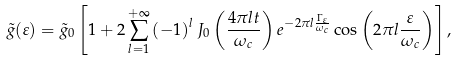<formula> <loc_0><loc_0><loc_500><loc_500>\tilde { g } ( \varepsilon ) = \tilde { g } _ { 0 } \left [ 1 + 2 \sum _ { l = 1 } ^ { + \infty } \left ( - 1 \right ) ^ { l } J _ { 0 } \left ( \frac { 4 \pi l t } { \omega _ { c } } \right ) e ^ { - 2 \pi l \frac { \Gamma _ { \varepsilon } } { \omega _ { c } } } \cos \left ( 2 \pi l \frac { \varepsilon } { \omega _ { c } } \right ) \right ] ,</formula> 